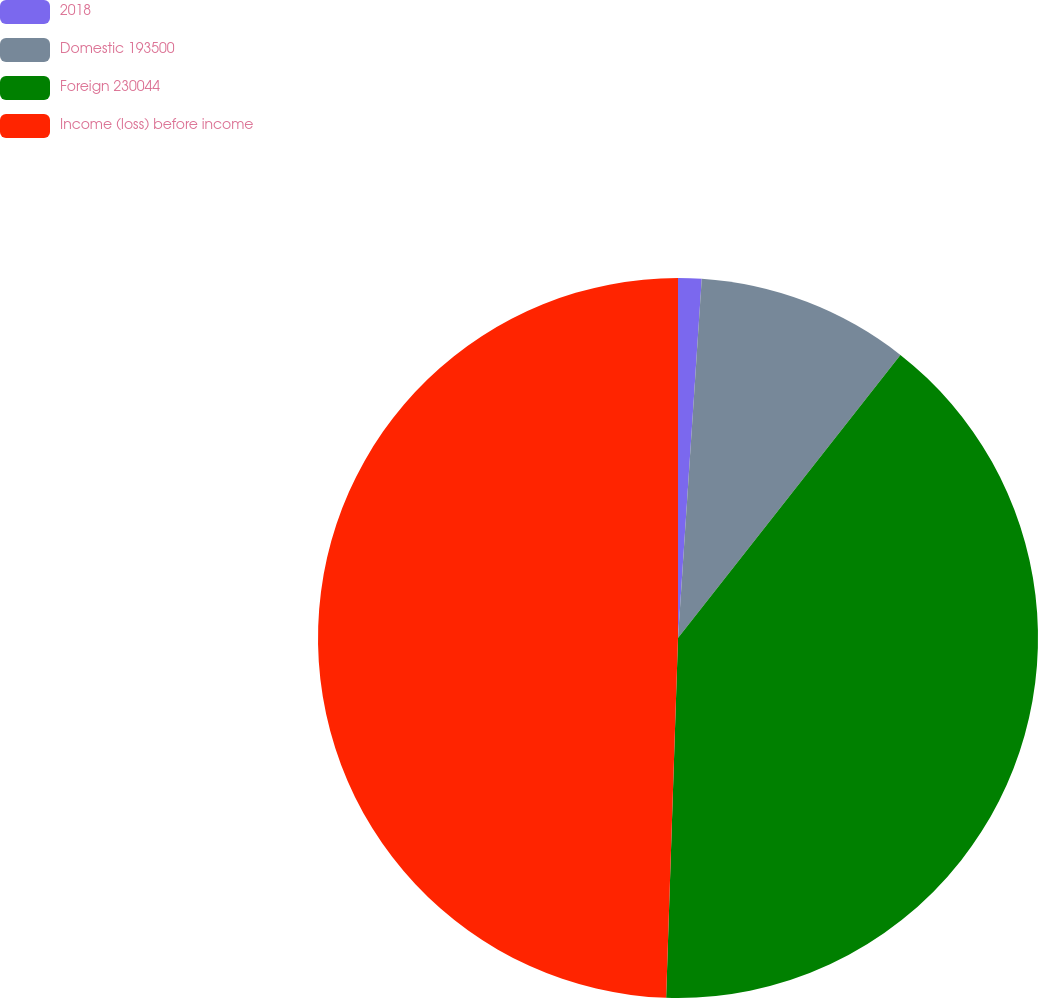Convert chart. <chart><loc_0><loc_0><loc_500><loc_500><pie_chart><fcel>2018<fcel>Domestic 193500<fcel>Foreign 230044<fcel>Income (loss) before income<nl><fcel>1.05%<fcel>9.55%<fcel>39.93%<fcel>49.48%<nl></chart> 